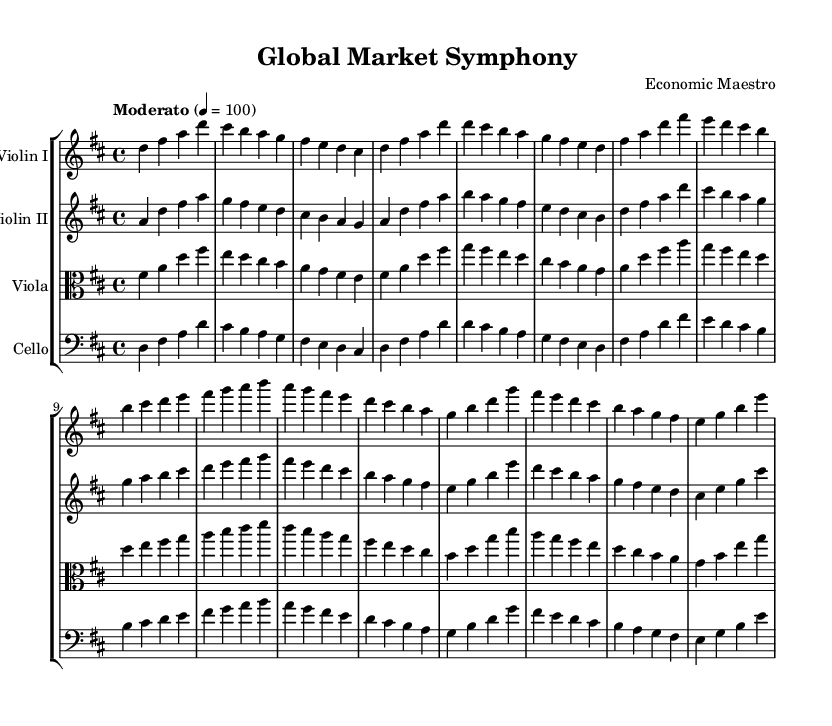What is the key signature of this music? The key signature is D major, which has two sharps (F# and C#). This can be identified by looking at the beginning of the staff where the sharps are indicated.
Answer: D major What is the time signature of this music? The time signature is 4/4, commonly known as "four-four" time, which indicates four beats per measure and a quarter note receives one beat. This can be found at the beginning of the staff before the notes start.
Answer: 4/4 What is the tempo marking of this piece? The tempo marking is "Moderato," which instructs the musicians to play at a moderate speed. This is indicated at the beginning of the score near the global settings.
Answer: Moderato How many measures are in the composition? There are 16 measures in the composition as counted by the number of vertical lines separating groups of notes across all instruments. Each group is a measure.
Answer: 16 What instruments are included in this orchestral composition? The instruments included are Violin I, Violin II, Viola, and Cello. This is noted at the beginning of each staff, where the instrument names are written.
Answer: Violin I, Violin II, Viola, Cello In which musical style or context could this piece be categorized? This piece could be categorized as a "symphony," as it features orchestral elements and multiple sections for different instruments, typically aligning with classical orchestral compositions.
Answer: Symphony 